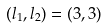Convert formula to latex. <formula><loc_0><loc_0><loc_500><loc_500>( l _ { 1 } , l _ { 2 } ) = ( 3 , 3 )</formula> 